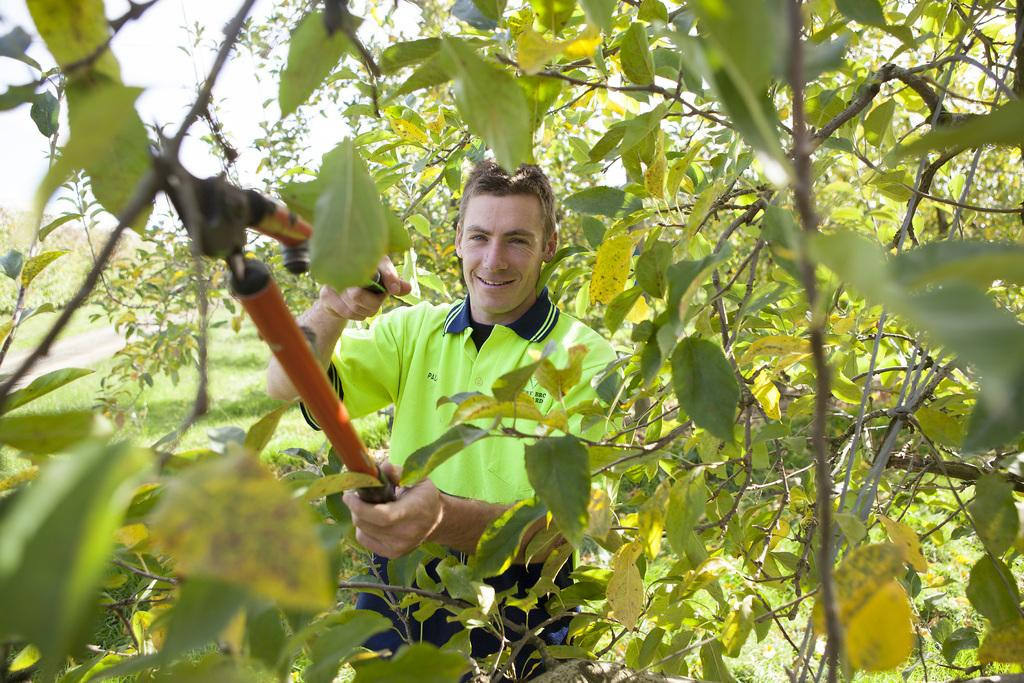Who is present in the image? There is a man in the image. What is the man doing in the image? The man is cutting a tree. What tool is the man using to cut the tree? The man is using garden scissors to cut the tree. How does the man appear in the image? The man is smiling in the image. What type of lock is the man using to secure the tree in the image? There is no lock present in the image; the man is using garden scissors to cut the tree. 